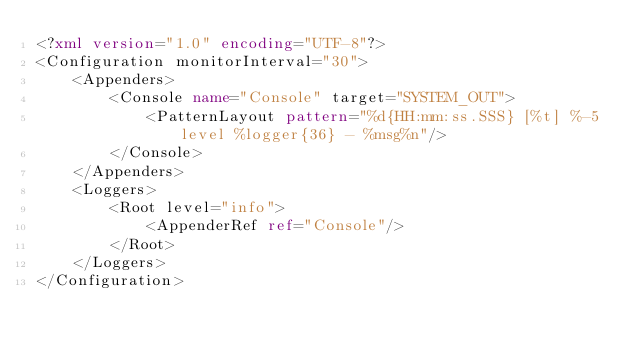<code> <loc_0><loc_0><loc_500><loc_500><_XML_><?xml version="1.0" encoding="UTF-8"?>
<Configuration monitorInterval="30">
    <Appenders>
        <Console name="Console" target="SYSTEM_OUT">
            <PatternLayout pattern="%d{HH:mm:ss.SSS} [%t] %-5level %logger{36} - %msg%n"/>
        </Console>
    </Appenders>
    <Loggers>
        <Root level="info">
            <AppenderRef ref="Console"/>
        </Root>
    </Loggers>
</Configuration></code> 